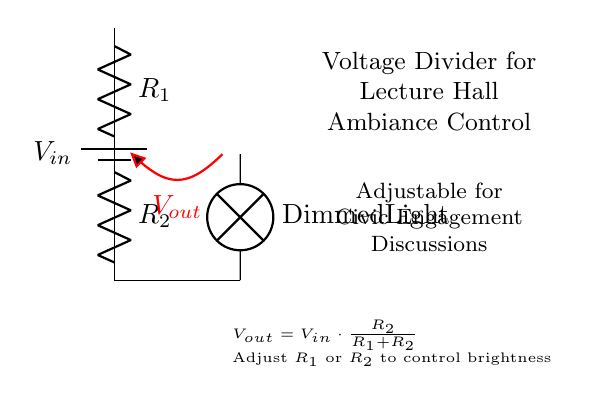What is the input voltage represented in this circuit? The input voltage, represented as \(V_{in}\), is the voltage supplied by the battery in the circuit. It indicates the total voltage available for the voltage divider to distribute among its components.
Answer: Vin What are the two resistors in this circuit? The circuit contains two resistors labeled \(R_1\) and \(R_2\). These resistors are key components of the voltage divider, determining how the input voltage is shared between them.
Answer: R1, R2 What is the output voltage in terms of the input voltage? The output voltage \(V_{out}\) is calculated using the formula \(V_{out} = V_{in} \cdot \frac{R_2}{R_1 + R_2}\). This shows how much of the input voltage is available across \(R_2\) and therefore across the light bulb when it is connected.
Answer: Vout = Vin * (R2 / (R1 + R2)) If resistor \(R_2\) is increased, what happens to the light's brightness? If \(R_2\) is increased, the output voltage \(V_{out}\) increases, which results in brighter light being emitted from the dimmed light bulb connected to the circuit. This is because the larger resistance allows for a higher proportion of the input voltage to appear across the light bulb.
Answer: Brightness increases How is the dimmed light bulb connected in the circuit? The dimmed light bulb is connected in series with the output voltage node \(V_{out}\). This means that the light bulb receives its voltage from the voltage divider arrangement, which adjusts the voltage for brightness control during discussions.
Answer: In series What component controls the brightness of the light? The brightness of the light is controlled by the resistors \(R_1\) and \(R_2\) in the voltage divider circuit. By adjusting either of these resistances, the voltage \(V_{out}\) can be altered, thus changing the brightness of the light bulb.
Answer: R1, R2 